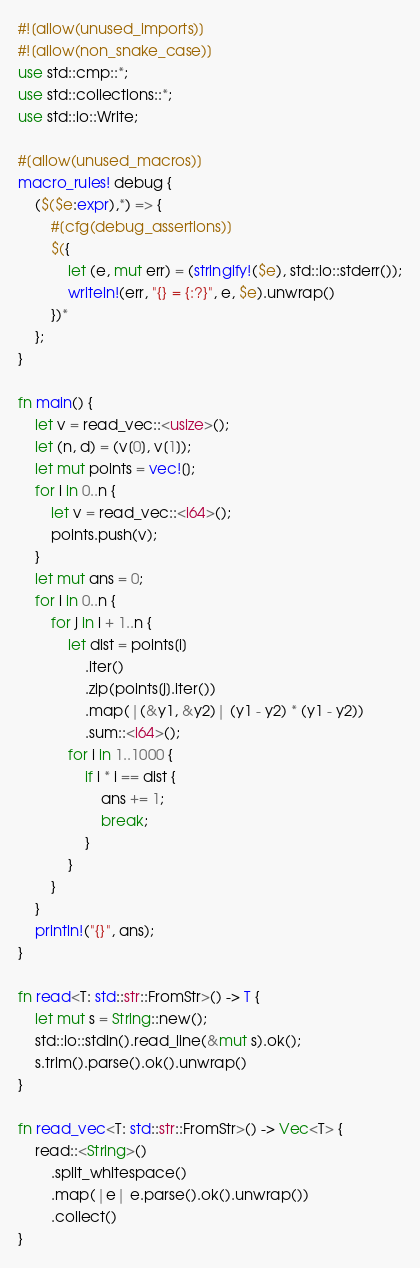<code> <loc_0><loc_0><loc_500><loc_500><_Rust_>#![allow(unused_imports)]
#![allow(non_snake_case)]
use std::cmp::*;
use std::collections::*;
use std::io::Write;

#[allow(unused_macros)]
macro_rules! debug {
    ($($e:expr),*) => {
        #[cfg(debug_assertions)]
        $({
            let (e, mut err) = (stringify!($e), std::io::stderr());
            writeln!(err, "{} = {:?}", e, $e).unwrap()
        })*
    };
}

fn main() {
    let v = read_vec::<usize>();
    let (n, d) = (v[0], v[1]);
    let mut points = vec![];
    for i in 0..n {
        let v = read_vec::<i64>();
        points.push(v);
    }
    let mut ans = 0;
    for i in 0..n {
        for j in i + 1..n {
            let dist = points[i]
                .iter()
                .zip(points[j].iter())
                .map(|(&y1, &y2)| (y1 - y2) * (y1 - y2))
                .sum::<i64>();
            for i in 1..1000 {
                if i * i == dist {
                    ans += 1;
                    break;
                }
            }
        }
    }
    println!("{}", ans);
}

fn read<T: std::str::FromStr>() -> T {
    let mut s = String::new();
    std::io::stdin().read_line(&mut s).ok();
    s.trim().parse().ok().unwrap()
}

fn read_vec<T: std::str::FromStr>() -> Vec<T> {
    read::<String>()
        .split_whitespace()
        .map(|e| e.parse().ok().unwrap())
        .collect()
}
</code> 